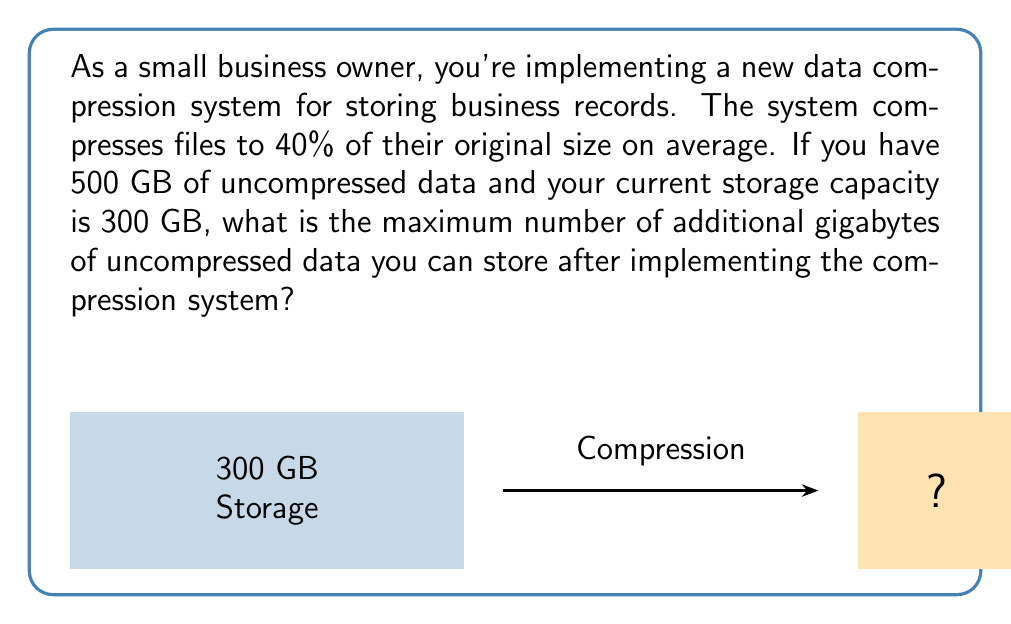Can you answer this question? Let's approach this step-by-step:

1) First, we need to calculate how much space the current 500 GB of data will occupy after compression:
   
   $$\text{Compressed size} = 500 \text{ GB} \times 0.40 = 200 \text{ GB}$$

2) This means that after compressing the existing data, we'll have some free space:
   
   $$\text{Free space} = 300 \text{ GB} - 200 \text{ GB} = 100 \text{ GB}$$

3) Now, we need to determine how much uncompressed data can fit into this 100 GB of free space. Let x be the amount of uncompressed data in GB. After compression, it will occupy 40% of x:
   
   $$0.40x = 100 \text{ GB}$$

4) Solving for x:
   
   $$x = 100 \text{ GB} \div 0.40 = 250 \text{ GB}$$

5) Therefore, we can store an additional 250 GB of uncompressed data.
Answer: 250 GB 